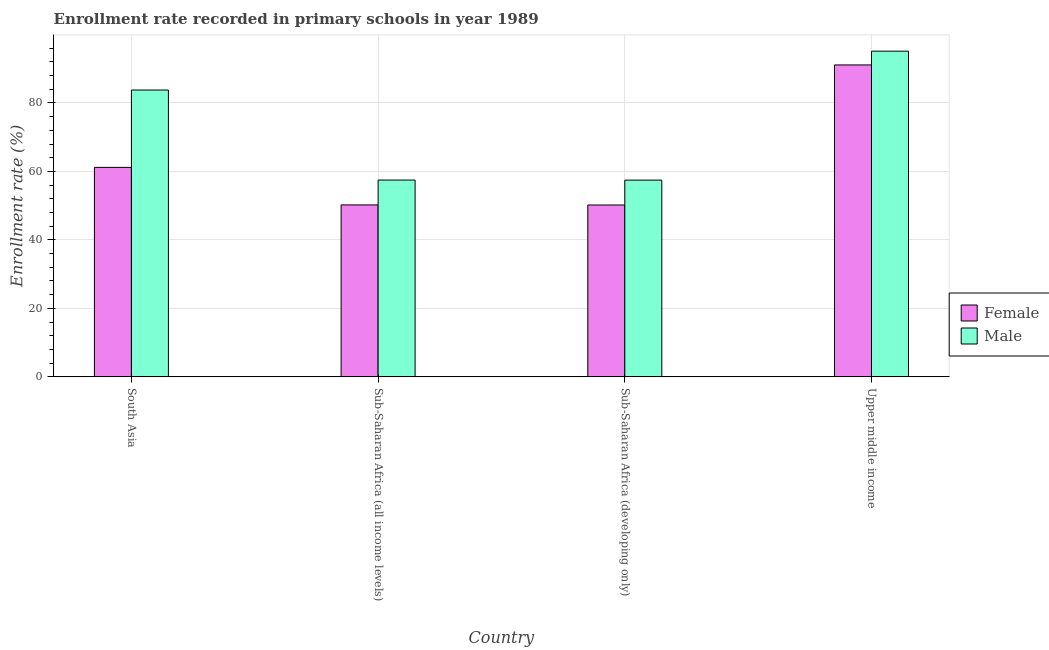Are the number of bars on each tick of the X-axis equal?
Ensure brevity in your answer.  Yes. How many bars are there on the 1st tick from the right?
Your answer should be compact. 2. What is the label of the 4th group of bars from the left?
Your response must be concise. Upper middle income. In how many cases, is the number of bars for a given country not equal to the number of legend labels?
Make the answer very short. 0. What is the enrollment rate of male students in South Asia?
Your answer should be very brief. 83.77. Across all countries, what is the maximum enrollment rate of male students?
Your response must be concise. 95.12. Across all countries, what is the minimum enrollment rate of female students?
Provide a succinct answer. 50.19. In which country was the enrollment rate of female students maximum?
Provide a succinct answer. Upper middle income. In which country was the enrollment rate of female students minimum?
Make the answer very short. Sub-Saharan Africa (developing only). What is the total enrollment rate of male students in the graph?
Ensure brevity in your answer.  293.84. What is the difference between the enrollment rate of female students in South Asia and that in Sub-Saharan Africa (all income levels)?
Provide a short and direct response. 10.96. What is the difference between the enrollment rate of female students in Sub-Saharan Africa (developing only) and the enrollment rate of male students in Upper middle income?
Provide a succinct answer. -44.93. What is the average enrollment rate of male students per country?
Make the answer very short. 73.46. What is the difference between the enrollment rate of female students and enrollment rate of male students in South Asia?
Provide a succinct answer. -22.59. What is the ratio of the enrollment rate of male students in South Asia to that in Sub-Saharan Africa (developing only)?
Offer a terse response. 1.46. Is the enrollment rate of female students in South Asia less than that in Sub-Saharan Africa (developing only)?
Your response must be concise. No. Is the difference between the enrollment rate of male students in South Asia and Sub-Saharan Africa (developing only) greater than the difference between the enrollment rate of female students in South Asia and Sub-Saharan Africa (developing only)?
Offer a terse response. Yes. What is the difference between the highest and the second highest enrollment rate of female students?
Provide a succinct answer. 29.92. What is the difference between the highest and the lowest enrollment rate of male students?
Offer a terse response. 37.66. Is the sum of the enrollment rate of female students in Sub-Saharan Africa (all income levels) and Upper middle income greater than the maximum enrollment rate of male students across all countries?
Give a very brief answer. Yes. What does the 1st bar from the left in Sub-Saharan Africa (developing only) represents?
Provide a succinct answer. Female. What does the 2nd bar from the right in Sub-Saharan Africa (all income levels) represents?
Your response must be concise. Female. What is the difference between two consecutive major ticks on the Y-axis?
Keep it short and to the point. 20. Where does the legend appear in the graph?
Your answer should be compact. Center right. What is the title of the graph?
Your response must be concise. Enrollment rate recorded in primary schools in year 1989. What is the label or title of the X-axis?
Give a very brief answer. Country. What is the label or title of the Y-axis?
Ensure brevity in your answer.  Enrollment rate (%). What is the Enrollment rate (%) of Female in South Asia?
Offer a very short reply. 61.18. What is the Enrollment rate (%) of Male in South Asia?
Offer a very short reply. 83.77. What is the Enrollment rate (%) of Female in Sub-Saharan Africa (all income levels)?
Make the answer very short. 50.22. What is the Enrollment rate (%) in Male in Sub-Saharan Africa (all income levels)?
Provide a short and direct response. 57.48. What is the Enrollment rate (%) in Female in Sub-Saharan Africa (developing only)?
Offer a very short reply. 50.19. What is the Enrollment rate (%) in Male in Sub-Saharan Africa (developing only)?
Your response must be concise. 57.46. What is the Enrollment rate (%) of Female in Upper middle income?
Ensure brevity in your answer.  91.1. What is the Enrollment rate (%) of Male in Upper middle income?
Your answer should be very brief. 95.12. Across all countries, what is the maximum Enrollment rate (%) in Female?
Your answer should be compact. 91.1. Across all countries, what is the maximum Enrollment rate (%) in Male?
Provide a succinct answer. 95.12. Across all countries, what is the minimum Enrollment rate (%) of Female?
Provide a succinct answer. 50.19. Across all countries, what is the minimum Enrollment rate (%) of Male?
Your response must be concise. 57.46. What is the total Enrollment rate (%) of Female in the graph?
Make the answer very short. 252.69. What is the total Enrollment rate (%) in Male in the graph?
Provide a succinct answer. 293.84. What is the difference between the Enrollment rate (%) of Female in South Asia and that in Sub-Saharan Africa (all income levels)?
Offer a terse response. 10.96. What is the difference between the Enrollment rate (%) of Male in South Asia and that in Sub-Saharan Africa (all income levels)?
Offer a terse response. 26.29. What is the difference between the Enrollment rate (%) of Female in South Asia and that in Sub-Saharan Africa (developing only)?
Provide a succinct answer. 10.98. What is the difference between the Enrollment rate (%) of Male in South Asia and that in Sub-Saharan Africa (developing only)?
Your response must be concise. 26.31. What is the difference between the Enrollment rate (%) in Female in South Asia and that in Upper middle income?
Give a very brief answer. -29.92. What is the difference between the Enrollment rate (%) in Male in South Asia and that in Upper middle income?
Offer a terse response. -11.35. What is the difference between the Enrollment rate (%) in Female in Sub-Saharan Africa (all income levels) and that in Sub-Saharan Africa (developing only)?
Provide a short and direct response. 0.02. What is the difference between the Enrollment rate (%) of Male in Sub-Saharan Africa (all income levels) and that in Sub-Saharan Africa (developing only)?
Your answer should be very brief. 0.02. What is the difference between the Enrollment rate (%) in Female in Sub-Saharan Africa (all income levels) and that in Upper middle income?
Provide a succinct answer. -40.88. What is the difference between the Enrollment rate (%) in Male in Sub-Saharan Africa (all income levels) and that in Upper middle income?
Ensure brevity in your answer.  -37.64. What is the difference between the Enrollment rate (%) of Female in Sub-Saharan Africa (developing only) and that in Upper middle income?
Make the answer very short. -40.91. What is the difference between the Enrollment rate (%) in Male in Sub-Saharan Africa (developing only) and that in Upper middle income?
Provide a succinct answer. -37.66. What is the difference between the Enrollment rate (%) of Female in South Asia and the Enrollment rate (%) of Male in Sub-Saharan Africa (all income levels)?
Give a very brief answer. 3.7. What is the difference between the Enrollment rate (%) of Female in South Asia and the Enrollment rate (%) of Male in Sub-Saharan Africa (developing only)?
Your answer should be very brief. 3.72. What is the difference between the Enrollment rate (%) in Female in South Asia and the Enrollment rate (%) in Male in Upper middle income?
Your response must be concise. -33.94. What is the difference between the Enrollment rate (%) of Female in Sub-Saharan Africa (all income levels) and the Enrollment rate (%) of Male in Sub-Saharan Africa (developing only)?
Provide a short and direct response. -7.24. What is the difference between the Enrollment rate (%) in Female in Sub-Saharan Africa (all income levels) and the Enrollment rate (%) in Male in Upper middle income?
Ensure brevity in your answer.  -44.9. What is the difference between the Enrollment rate (%) in Female in Sub-Saharan Africa (developing only) and the Enrollment rate (%) in Male in Upper middle income?
Your answer should be very brief. -44.93. What is the average Enrollment rate (%) of Female per country?
Keep it short and to the point. 63.17. What is the average Enrollment rate (%) in Male per country?
Your answer should be very brief. 73.46. What is the difference between the Enrollment rate (%) in Female and Enrollment rate (%) in Male in South Asia?
Your answer should be compact. -22.59. What is the difference between the Enrollment rate (%) of Female and Enrollment rate (%) of Male in Sub-Saharan Africa (all income levels)?
Offer a terse response. -7.26. What is the difference between the Enrollment rate (%) of Female and Enrollment rate (%) of Male in Sub-Saharan Africa (developing only)?
Provide a succinct answer. -7.27. What is the difference between the Enrollment rate (%) in Female and Enrollment rate (%) in Male in Upper middle income?
Offer a terse response. -4.02. What is the ratio of the Enrollment rate (%) in Female in South Asia to that in Sub-Saharan Africa (all income levels)?
Provide a succinct answer. 1.22. What is the ratio of the Enrollment rate (%) in Male in South Asia to that in Sub-Saharan Africa (all income levels)?
Your response must be concise. 1.46. What is the ratio of the Enrollment rate (%) in Female in South Asia to that in Sub-Saharan Africa (developing only)?
Your response must be concise. 1.22. What is the ratio of the Enrollment rate (%) in Male in South Asia to that in Sub-Saharan Africa (developing only)?
Your response must be concise. 1.46. What is the ratio of the Enrollment rate (%) of Female in South Asia to that in Upper middle income?
Make the answer very short. 0.67. What is the ratio of the Enrollment rate (%) in Male in South Asia to that in Upper middle income?
Offer a very short reply. 0.88. What is the ratio of the Enrollment rate (%) in Female in Sub-Saharan Africa (all income levels) to that in Sub-Saharan Africa (developing only)?
Ensure brevity in your answer.  1. What is the ratio of the Enrollment rate (%) of Female in Sub-Saharan Africa (all income levels) to that in Upper middle income?
Keep it short and to the point. 0.55. What is the ratio of the Enrollment rate (%) of Male in Sub-Saharan Africa (all income levels) to that in Upper middle income?
Give a very brief answer. 0.6. What is the ratio of the Enrollment rate (%) of Female in Sub-Saharan Africa (developing only) to that in Upper middle income?
Your response must be concise. 0.55. What is the ratio of the Enrollment rate (%) of Male in Sub-Saharan Africa (developing only) to that in Upper middle income?
Provide a short and direct response. 0.6. What is the difference between the highest and the second highest Enrollment rate (%) in Female?
Provide a short and direct response. 29.92. What is the difference between the highest and the second highest Enrollment rate (%) of Male?
Offer a terse response. 11.35. What is the difference between the highest and the lowest Enrollment rate (%) in Female?
Provide a succinct answer. 40.91. What is the difference between the highest and the lowest Enrollment rate (%) in Male?
Give a very brief answer. 37.66. 